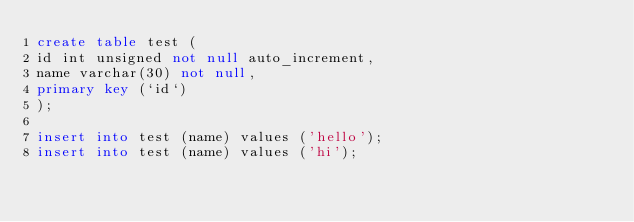Convert code to text. <code><loc_0><loc_0><loc_500><loc_500><_SQL_>create table test (
id int unsigned not null auto_increment,
name varchar(30) not null,
primary key (`id`)
);

insert into test (name) values ('hello');
insert into test (name) values ('hi');</code> 